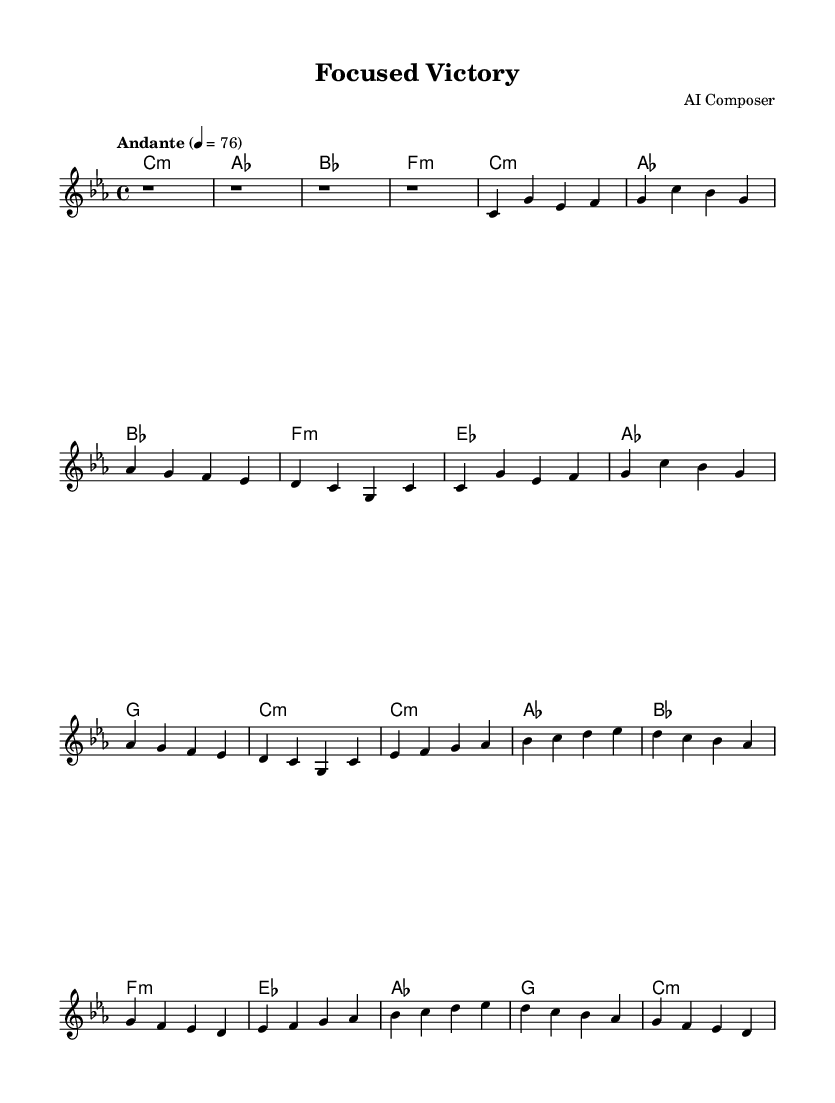What is the key signature of this music? The key signature is C minor, which is indicated by the presence of three flats (B♭, E♭, and A♭). In the sheet music, C minor is marked at the beginning with no accidentals, confirming the use of the key's standard flats.
Answer: C minor What is the time signature of this music? The time signature is 4/4, which is indicated at the beginning of the sheet music. Each measure contains four beats, and this can be confirmed by counting the subdivisions in each bar throughout the score.
Answer: 4/4 What is the tempo marking of the piece? The tempo marking is "Andante," which suggests a moderate pace. This is noted above the staff, giving the performer an indication of how quickly to play the piece.
Answer: Andante How many measures are in the Main Theme A? Main Theme A consists of eight measures. This can be identified by locating the two repeated phrases within the score, each contributing four measures to the total count.
Answer: Eight What are the chords used in the Intro section? The chords in the Intro are C minor, A♭ major, B♭ major, and F minor. This sequence can be observed in the chord symbols written above the corresponding measures, providing clarity on the harmonic structure of that section.
Answer: C minor, A♭ major, B♭ major, F minor Which section of the music introduces the Main Theme B? The Main Theme B is introduced after the first repetition of Main Theme A. Recalling the structure of the score, the transition to Theme B is clearly marked, indicating a shift from the previously established ideas.
Answer: Main Theme B 